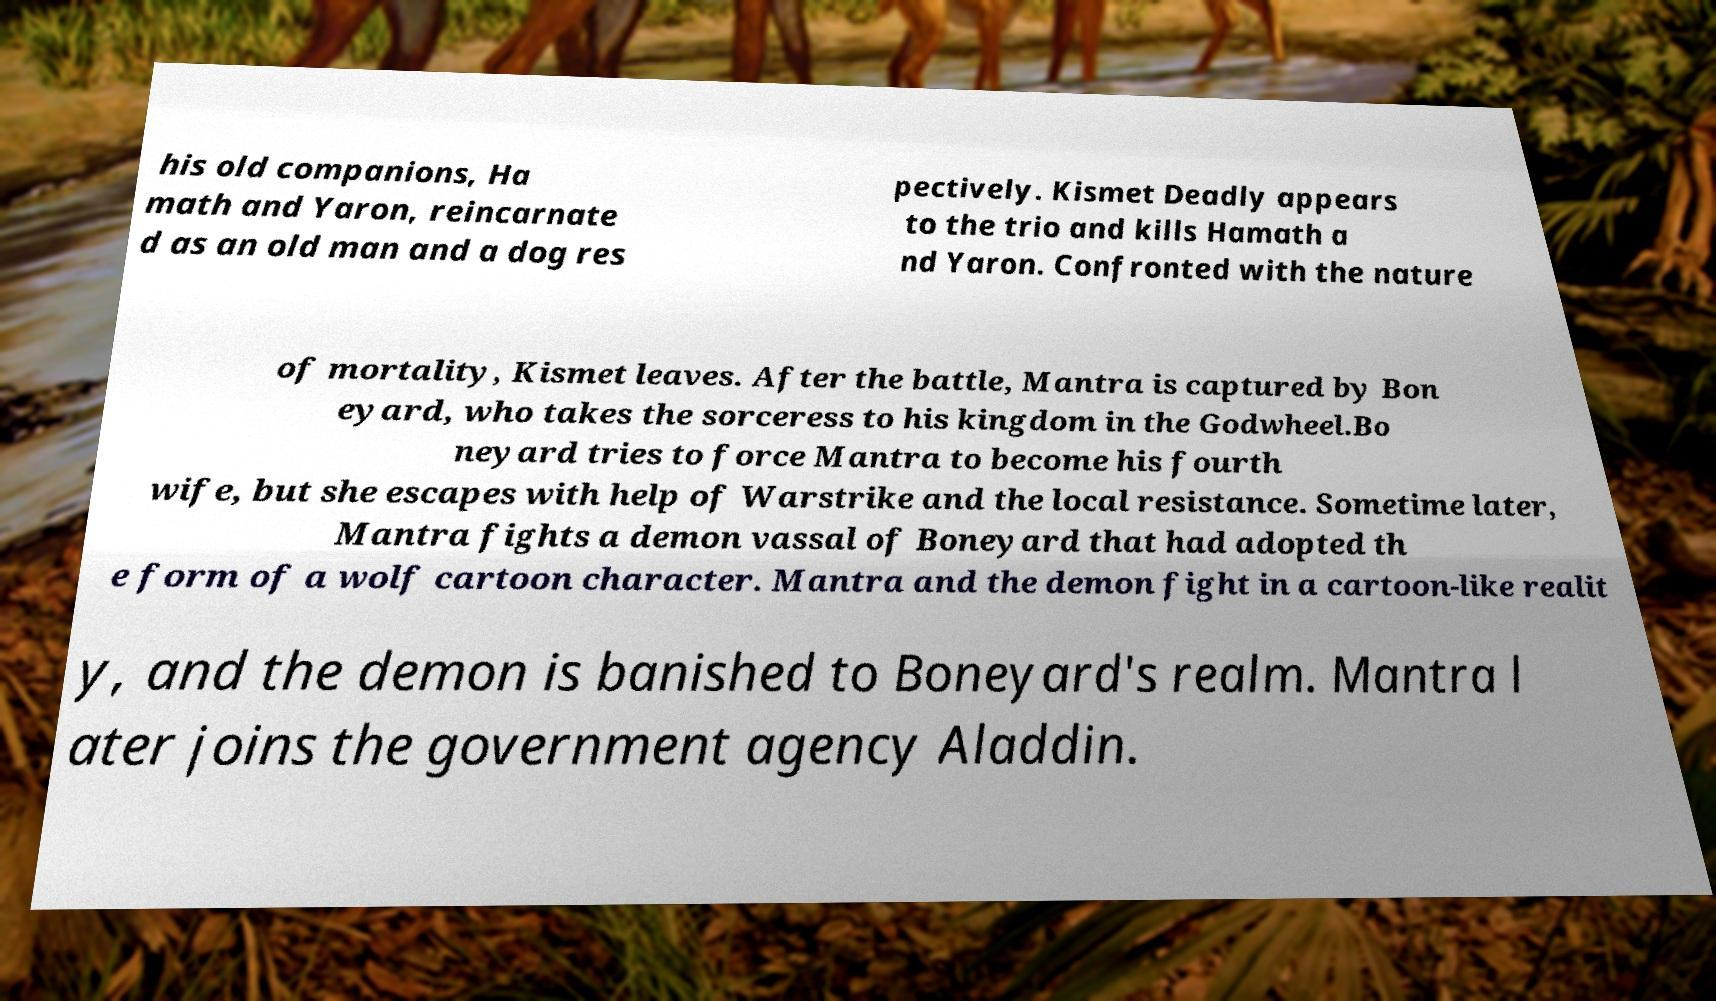There's text embedded in this image that I need extracted. Can you transcribe it verbatim? his old companions, Ha math and Yaron, reincarnate d as an old man and a dog res pectively. Kismet Deadly appears to the trio and kills Hamath a nd Yaron. Confronted with the nature of mortality, Kismet leaves. After the battle, Mantra is captured by Bon eyard, who takes the sorceress to his kingdom in the Godwheel.Bo neyard tries to force Mantra to become his fourth wife, but she escapes with help of Warstrike and the local resistance. Sometime later, Mantra fights a demon vassal of Boneyard that had adopted th e form of a wolf cartoon character. Mantra and the demon fight in a cartoon-like realit y, and the demon is banished to Boneyard's realm. Mantra l ater joins the government agency Aladdin. 